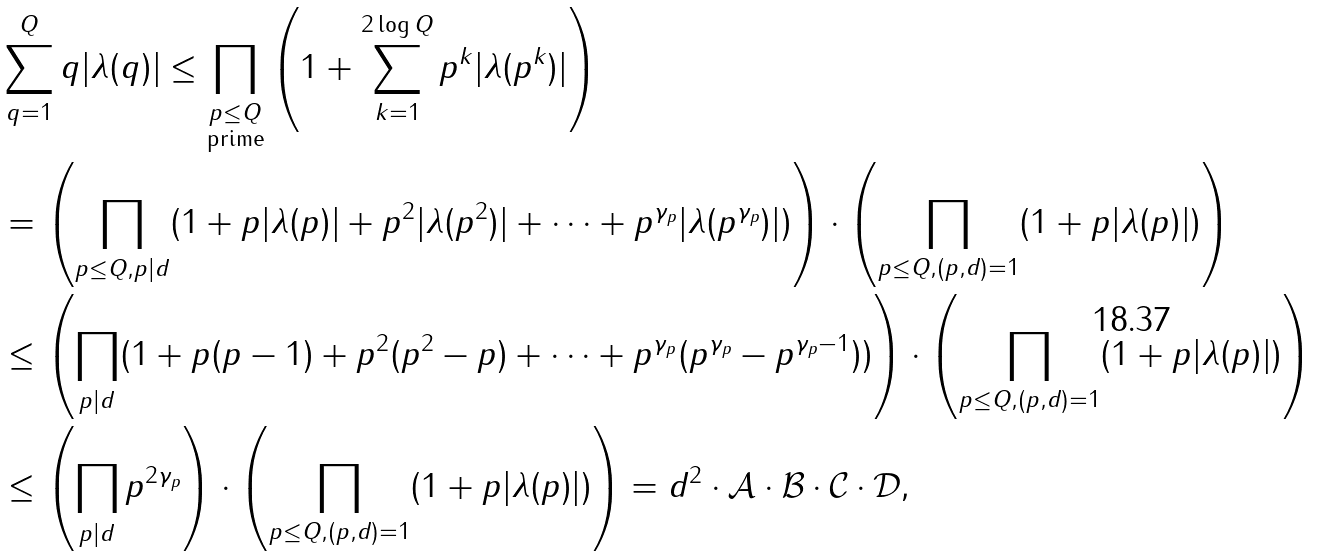<formula> <loc_0><loc_0><loc_500><loc_500>& \sum _ { q = 1 } ^ { Q } q | \lambda ( q ) | \leq \prod _ { \substack { p \leq Q \\ \text {prime} } } \left ( 1 + \sum _ { k = 1 } ^ { 2 \log Q } p ^ { k } | \lambda ( p ^ { k } ) | \right ) \\ & = \left ( \prod _ { p \leq Q , p | d } ( 1 + p | \lambda ( p ) | + p ^ { 2 } | \lambda ( p ^ { 2 } ) | + \dots + p ^ { \gamma _ { p } } | \lambda ( p ^ { \gamma _ { p } } ) | ) \right ) \cdot \left ( \prod _ { p \leq Q , ( p , d ) = 1 } ( 1 + p | \lambda ( p ) | ) \right ) \\ & \leq \left ( \prod _ { p | d } ( 1 + p ( p - 1 ) + p ^ { 2 } ( p ^ { 2 } - p ) + \dots + p ^ { \gamma _ { p } } ( p ^ { \gamma _ { p } } - p ^ { \gamma _ { p } - 1 } ) ) \right ) \cdot \left ( \prod _ { p \leq Q , ( p , d ) = 1 } ( 1 + p | \lambda ( p ) | ) \right ) \\ & \leq \left ( \prod _ { p | d } p ^ { 2 \gamma _ { p } } \right ) \cdot \left ( \prod _ { p \leq Q , ( p , d ) = 1 } ( 1 + p | \lambda ( p ) | ) \right ) = d ^ { 2 } \cdot \mathcal { A } \cdot \mathcal { B } \cdot \mathcal { C } \cdot \mathcal { D } ,</formula> 